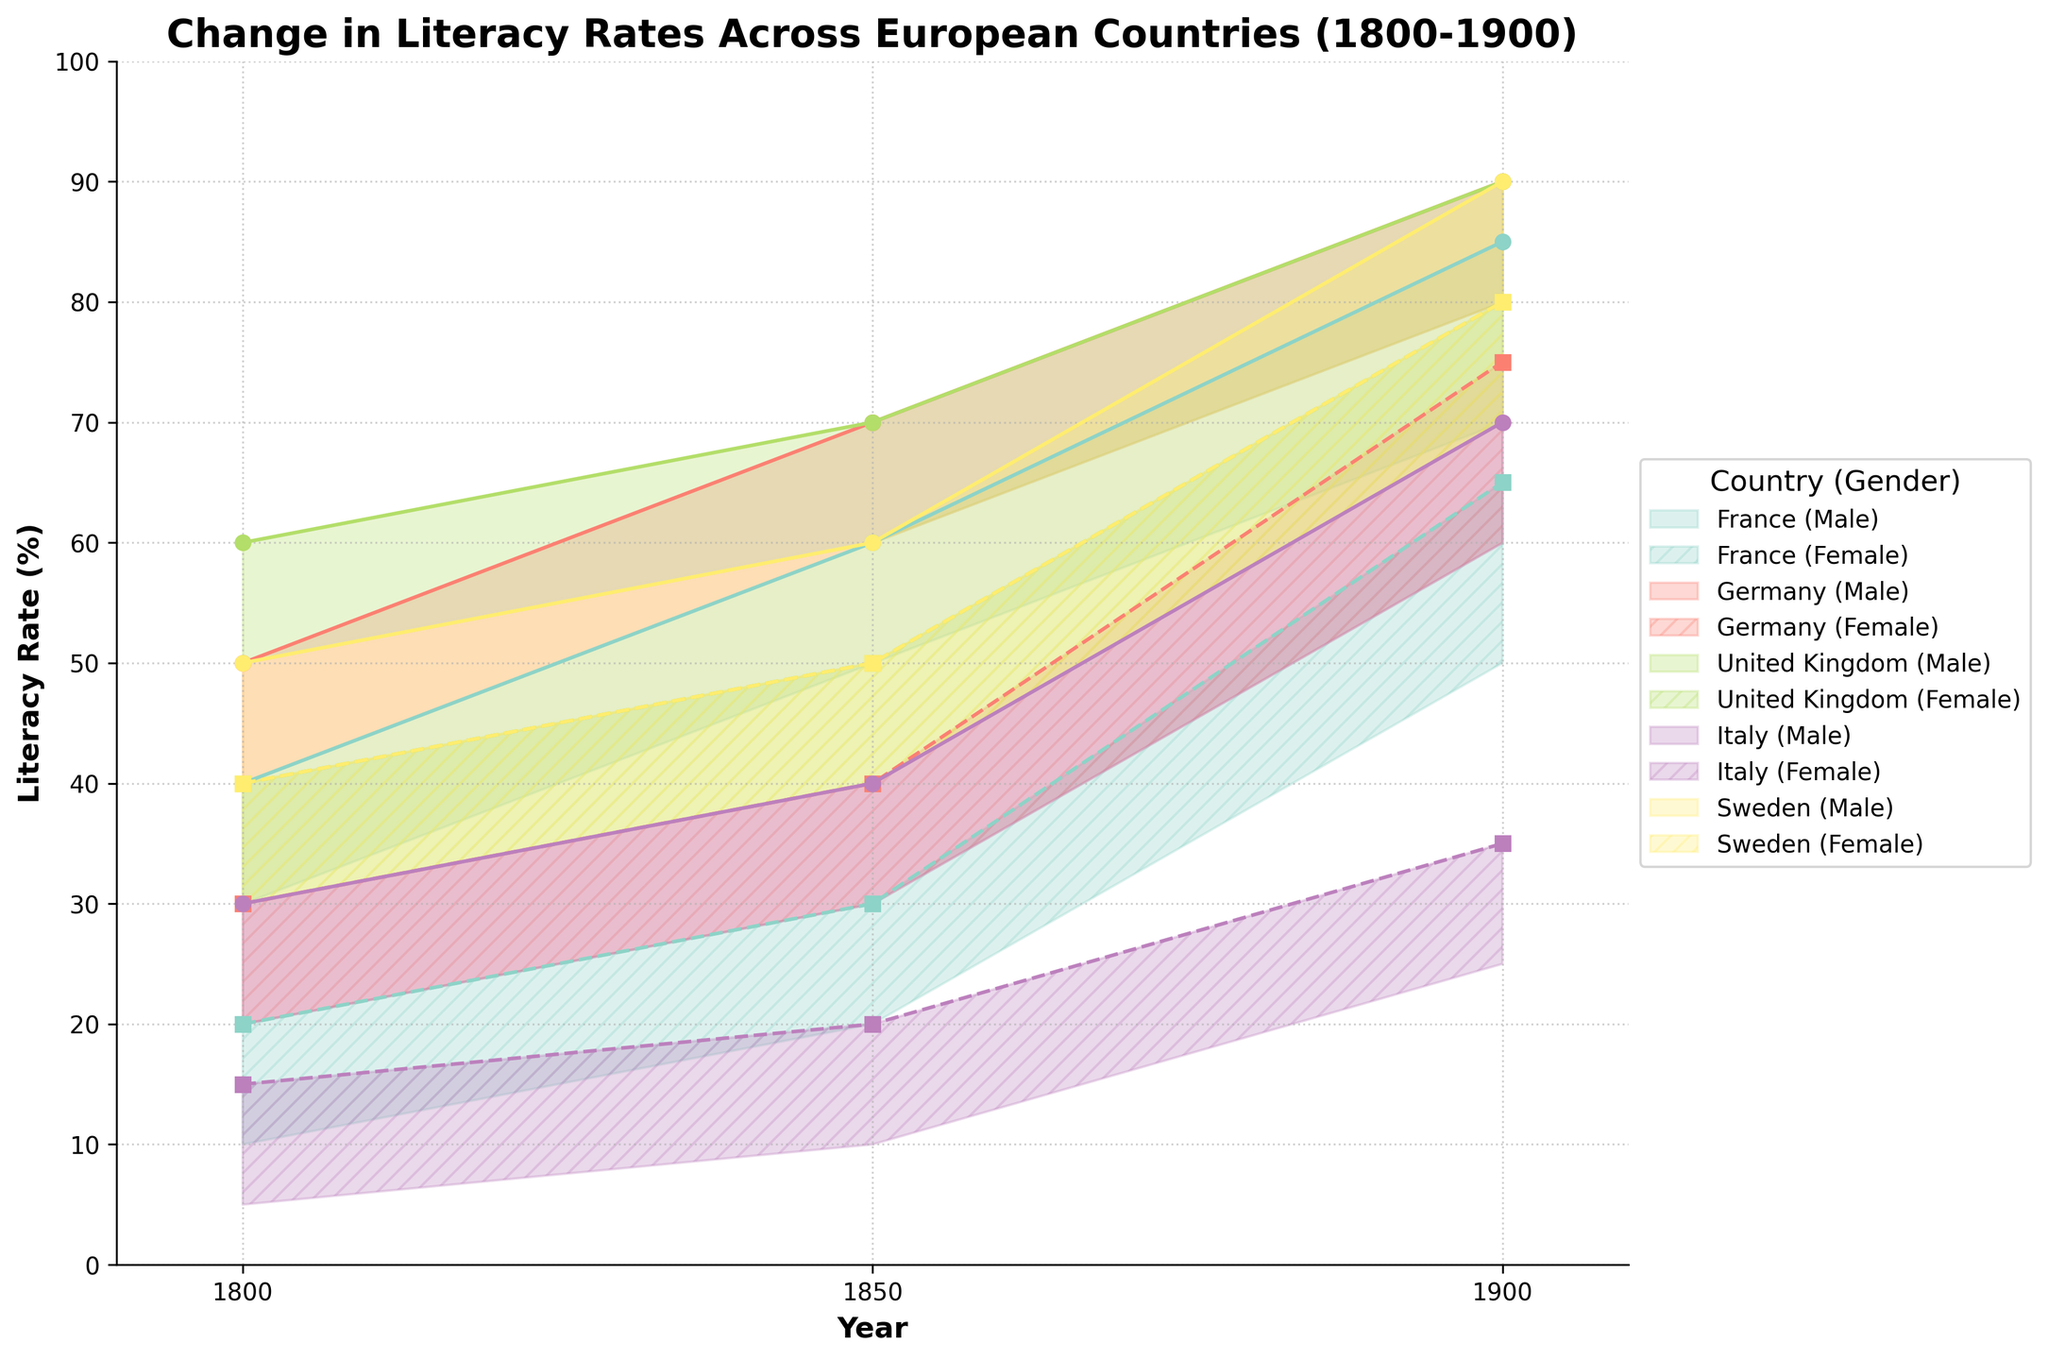What are the minimum and maximum literacy rates for males in France in 1850? Look for the shaded region representing France (Male) in 1850 and read the endpoints of the vertical span. The literacy rate ranges from 50% to 60%.
Answer: 50%-60% Between which years does the literacy rate for females in Sweden exceed 70%? Check the Sweden (Female) segment and observe the highest literacy rate lines. The shaded region exceeds 70% between 1900.
Answer: 1900 By how much did the literacy rate range for males in the United Kingdom change from 1800 to 1900? Calculate the difference between the max and min rates in 1800 and 1900 for UK males. In 1800, it's 50-60%, and in 1900, it's 80-90%. Both ranges span 10%, showing no change.
Answer: 0% Which country saw the highest maximum literacy rate for females in 1900? Compare the maximum literacy rates for females in 1900 across all countries. Both Sweden and the United Kingdom reach a maximum of 80%.
Answer: United Kingdom and Sweden How does the range of literacy rates for females in Italy in 1800 compare to that in 1900? Find ranges for Italy females in 1800 (5%-15%) and 1900 (25%-35%). Calculate and compare the spans: 15-5=10% in 1800, and 35-25=10% in 1900. They are the same.
Answer: Same (10%) In terms of the trend, which gender in Germany showed greater improvement in literacy rates from 1800 to 1900? Look at the rise in literacy rates for both genders in Germany. Males go from 40-50% to 80-90%, while females move from 20-30% to 60-75%. Bigger increase in males as they improve by 40%, females by 45%
Answer: Female Which country shows the least gender disparity in literacy rates in 1900? For each country in 1900, check the maximum rates for both genders and find the smallest difference. Sweden shows males at 80-90%, females at 70-80% - difference is 10%.
Answer: Sweden By what percentage did the minimum literacy rate for females in France increase from 1800 to 1900? In 1800, the minimum for France females is 10%; in 1900, it's 50%. Calculate (50-10)/10 * 100% = 400%.
Answer: 400% Which countries had a higher maximum literacy rate for females than that for males in 1850? Survey the literacy rate maximums for males and females in 1850. No country shows females surpassing males.
Answer: None 